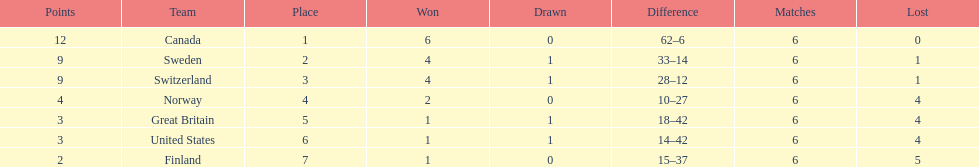What is the total number of teams to have 4 total wins? 2. 